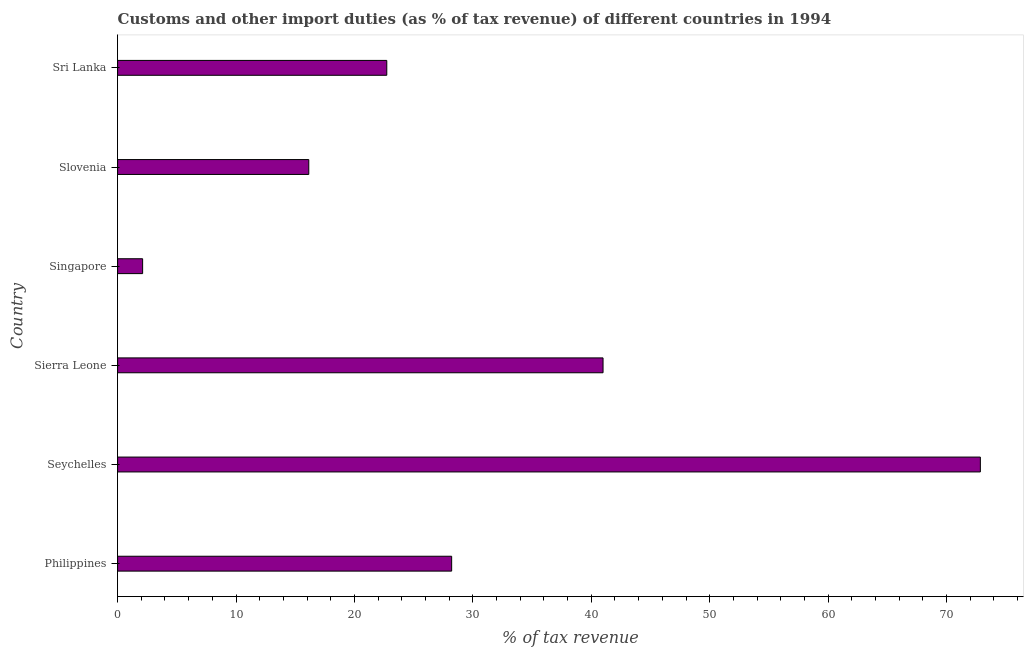Does the graph contain grids?
Give a very brief answer. No. What is the title of the graph?
Your answer should be compact. Customs and other import duties (as % of tax revenue) of different countries in 1994. What is the label or title of the X-axis?
Offer a very short reply. % of tax revenue. What is the label or title of the Y-axis?
Your response must be concise. Country. What is the customs and other import duties in Singapore?
Provide a succinct answer. 2.11. Across all countries, what is the maximum customs and other import duties?
Give a very brief answer. 72.86. Across all countries, what is the minimum customs and other import duties?
Your answer should be compact. 2.11. In which country was the customs and other import duties maximum?
Your answer should be very brief. Seychelles. In which country was the customs and other import duties minimum?
Keep it short and to the point. Singapore. What is the sum of the customs and other import duties?
Offer a very short reply. 183.05. What is the difference between the customs and other import duties in Seychelles and Sierra Leone?
Ensure brevity in your answer.  31.86. What is the average customs and other import duties per country?
Offer a very short reply. 30.51. What is the median customs and other import duties?
Your answer should be very brief. 25.47. What is the ratio of the customs and other import duties in Sierra Leone to that in Slovenia?
Provide a short and direct response. 2.54. Is the customs and other import duties in Seychelles less than that in Singapore?
Make the answer very short. No. Is the difference between the customs and other import duties in Seychelles and Sierra Leone greater than the difference between any two countries?
Provide a succinct answer. No. What is the difference between the highest and the second highest customs and other import duties?
Keep it short and to the point. 31.86. Is the sum of the customs and other import duties in Seychelles and Sierra Leone greater than the maximum customs and other import duties across all countries?
Your answer should be compact. Yes. What is the difference between the highest and the lowest customs and other import duties?
Your answer should be very brief. 70.74. In how many countries, is the customs and other import duties greater than the average customs and other import duties taken over all countries?
Offer a terse response. 2. Are all the bars in the graph horizontal?
Offer a terse response. Yes. How many countries are there in the graph?
Your answer should be compact. 6. What is the difference between two consecutive major ticks on the X-axis?
Your response must be concise. 10. What is the % of tax revenue in Philippines?
Make the answer very short. 28.21. What is the % of tax revenue in Seychelles?
Offer a terse response. 72.86. What is the % of tax revenue of Sierra Leone?
Your response must be concise. 40.99. What is the % of tax revenue in Singapore?
Ensure brevity in your answer.  2.11. What is the % of tax revenue of Slovenia?
Keep it short and to the point. 16.14. What is the % of tax revenue of Sri Lanka?
Provide a short and direct response. 22.73. What is the difference between the % of tax revenue in Philippines and Seychelles?
Your answer should be compact. -44.65. What is the difference between the % of tax revenue in Philippines and Sierra Leone?
Give a very brief answer. -12.78. What is the difference between the % of tax revenue in Philippines and Singapore?
Keep it short and to the point. 26.1. What is the difference between the % of tax revenue in Philippines and Slovenia?
Make the answer very short. 12.07. What is the difference between the % of tax revenue in Philippines and Sri Lanka?
Keep it short and to the point. 5.48. What is the difference between the % of tax revenue in Seychelles and Sierra Leone?
Keep it short and to the point. 31.86. What is the difference between the % of tax revenue in Seychelles and Singapore?
Make the answer very short. 70.74. What is the difference between the % of tax revenue in Seychelles and Slovenia?
Make the answer very short. 56.71. What is the difference between the % of tax revenue in Seychelles and Sri Lanka?
Keep it short and to the point. 50.13. What is the difference between the % of tax revenue in Sierra Leone and Singapore?
Ensure brevity in your answer.  38.88. What is the difference between the % of tax revenue in Sierra Leone and Slovenia?
Ensure brevity in your answer.  24.85. What is the difference between the % of tax revenue in Sierra Leone and Sri Lanka?
Your answer should be compact. 18.26. What is the difference between the % of tax revenue in Singapore and Slovenia?
Keep it short and to the point. -14.03. What is the difference between the % of tax revenue in Singapore and Sri Lanka?
Your answer should be compact. -20.62. What is the difference between the % of tax revenue in Slovenia and Sri Lanka?
Offer a very short reply. -6.59. What is the ratio of the % of tax revenue in Philippines to that in Seychelles?
Provide a short and direct response. 0.39. What is the ratio of the % of tax revenue in Philippines to that in Sierra Leone?
Your answer should be very brief. 0.69. What is the ratio of the % of tax revenue in Philippines to that in Singapore?
Give a very brief answer. 13.35. What is the ratio of the % of tax revenue in Philippines to that in Slovenia?
Offer a very short reply. 1.75. What is the ratio of the % of tax revenue in Philippines to that in Sri Lanka?
Your answer should be very brief. 1.24. What is the ratio of the % of tax revenue in Seychelles to that in Sierra Leone?
Ensure brevity in your answer.  1.78. What is the ratio of the % of tax revenue in Seychelles to that in Singapore?
Provide a short and direct response. 34.49. What is the ratio of the % of tax revenue in Seychelles to that in Slovenia?
Your answer should be compact. 4.51. What is the ratio of the % of tax revenue in Seychelles to that in Sri Lanka?
Keep it short and to the point. 3.21. What is the ratio of the % of tax revenue in Sierra Leone to that in Singapore?
Provide a short and direct response. 19.41. What is the ratio of the % of tax revenue in Sierra Leone to that in Slovenia?
Ensure brevity in your answer.  2.54. What is the ratio of the % of tax revenue in Sierra Leone to that in Sri Lanka?
Make the answer very short. 1.8. What is the ratio of the % of tax revenue in Singapore to that in Slovenia?
Your answer should be very brief. 0.13. What is the ratio of the % of tax revenue in Singapore to that in Sri Lanka?
Offer a very short reply. 0.09. What is the ratio of the % of tax revenue in Slovenia to that in Sri Lanka?
Offer a very short reply. 0.71. 